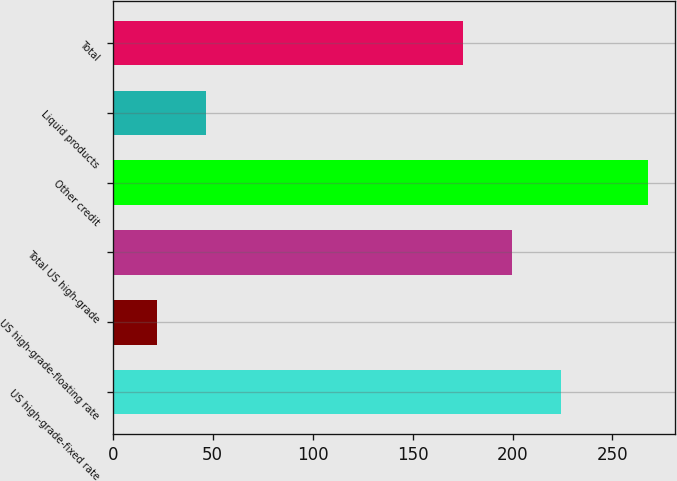<chart> <loc_0><loc_0><loc_500><loc_500><bar_chart><fcel>US high-grade-fixed rate<fcel>US high-grade-floating rate<fcel>Total US high-grade<fcel>Other credit<fcel>Liquid products<fcel>Total<nl><fcel>224.2<fcel>22<fcel>199.6<fcel>268<fcel>46.6<fcel>175<nl></chart> 